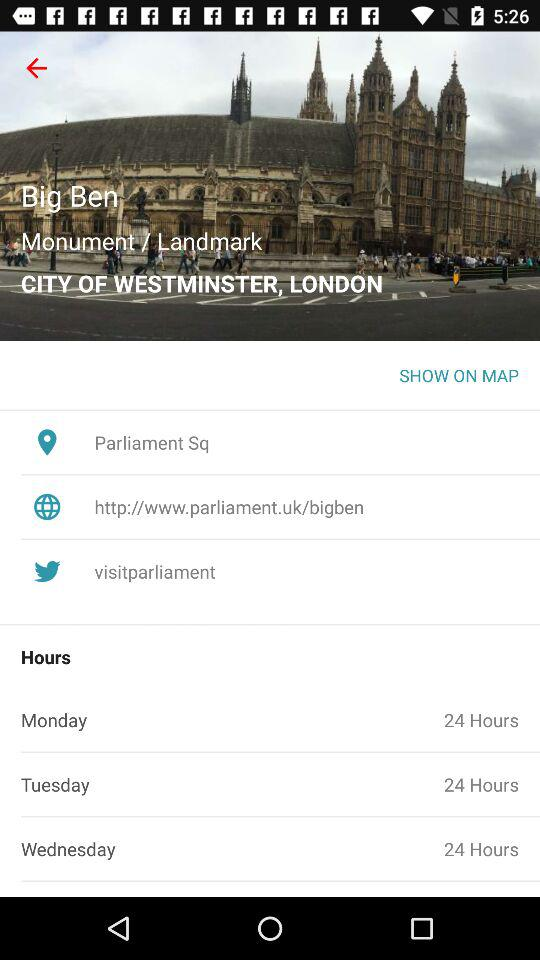What is the twitter account name? The twitter account name is "visitparliament". 